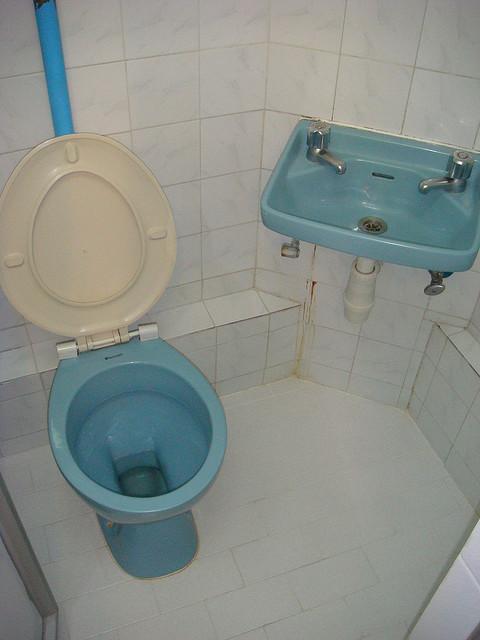What color is the plastic toilet?
Be succinct. Blue. Is the toilet seat down?
Give a very brief answer. No. What color is the bottom of the toilet?
Be succinct. Blue. What color is the sink?
Answer briefly. Blue. 